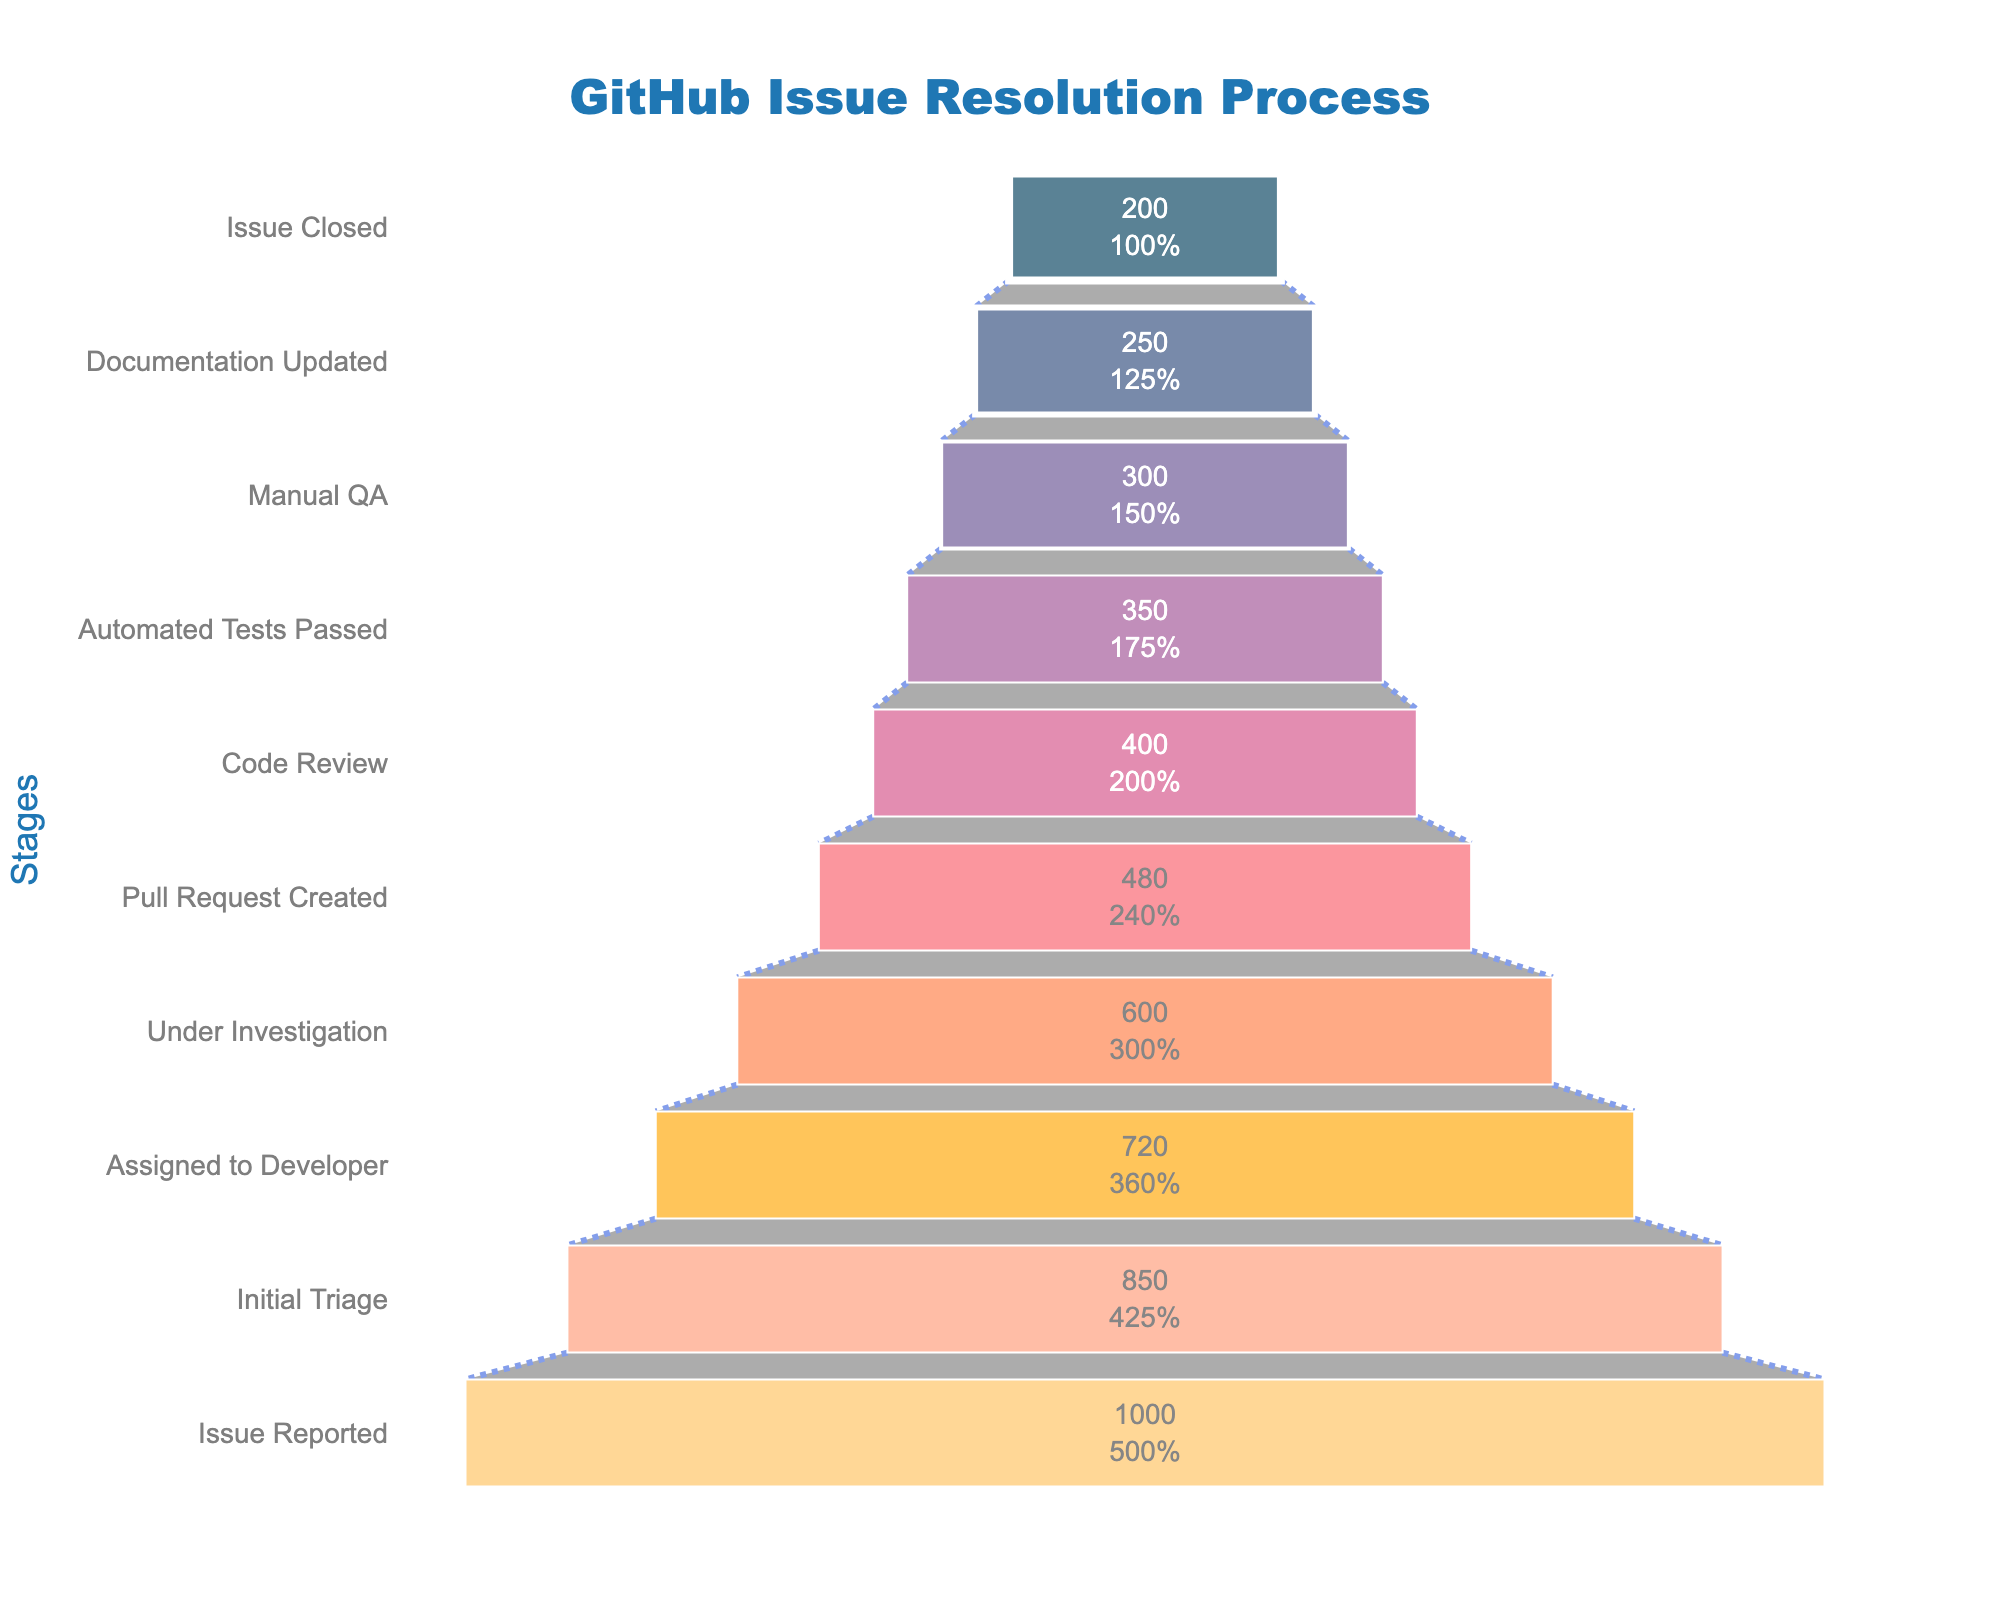What is the title of the funnel chart? The title of the funnel chart is displayed at the top center of the chart in large, bold font. By looking at the chart, we can see the title.
Answer: GitHub Issue Resolution Process How many stages are there in the process shown in the funnel chart? The funnel chart shows different stages in the process. By counting the number of stages listed along the y-axis, we can determine the total number.
Answer: 10 How many issues were closed eventually? The count of issues that reached the final stage "Issue Closed" can be read directly from the funnel chart. This value is shown at the bottom of the chart.
Answer: 200 Which stage has the highest number of issues, and what is that number? The number of issues for each stage is displayed along the x-axis, and the largest value can be identified by looking at the topmost segment of the funnel.
Answer: Issue Reported with 1000 issues What percentage of issues reported are closed? To find the percentage, divide the number of issues closed (200) by the number of issues reported (1000) and multiply by 100.
Answer: 20.0% How many issues are still pending from "Pull Request Created" stage onwards? Sum up the counts for stages from "Pull Request Created" to "Issue Closed" (480 + 400 + 350 + 300 + 250 + 200).
Answer: 1980 By how many issues does the "Under Investigation" stage decrease from the "Initial Triage" stage? Subtract the count at "Under Investigation" (600) from the count at "Initial Triage" (850).
Answer: 250 What is the difference in the number of issues between "Manual QA" and "Documentation Updated"? Subtract the count of issues at "Documentation Updated" (250) from the count at "Manual QA" (300).
Answer: 50 Which stage follows "Assigned to Developer"? Look at the order of stages on the y-axis and identify which stage appears immediately after "Assigned to Developer".
Answer: Under Investigation What is the cumulative decrease in the number of issues from "Automated Tests Passed" to "Issue Closed"? Calculate the difference between the numbers of issues at "Automated Tests Passed" (350) and "Issue Closed" (200).
Answer: 150 